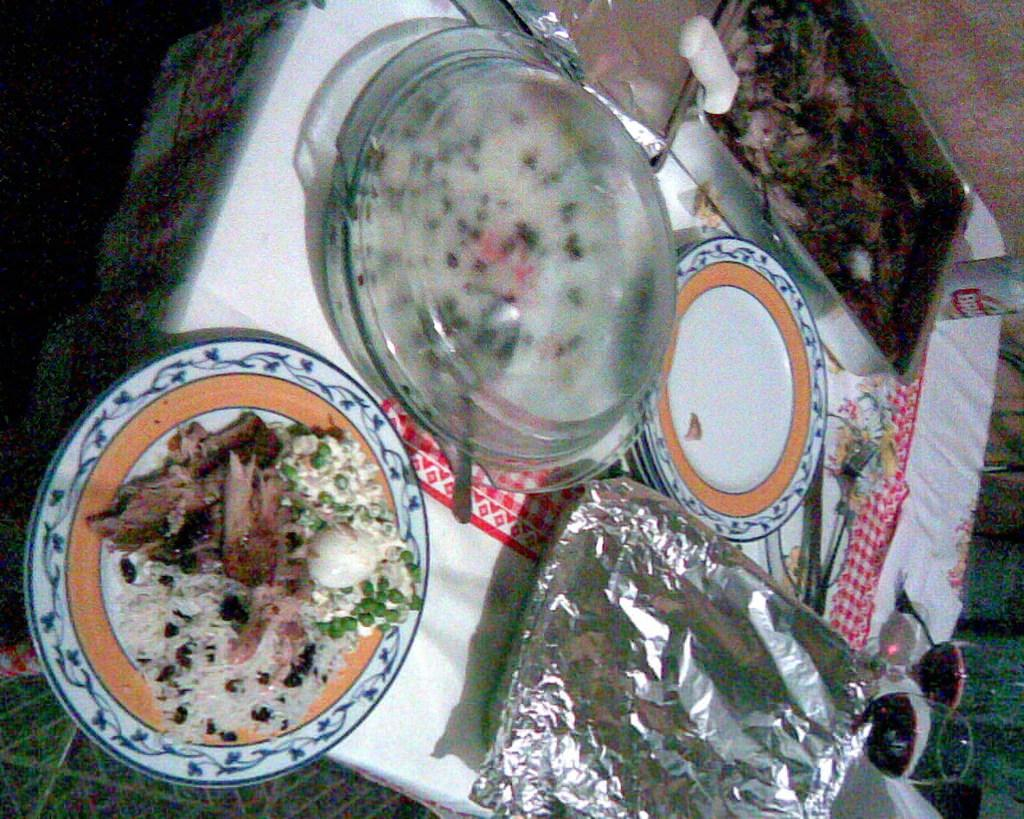What is the main piece of furniture in the image? There is a table in the image. Where is the table located? The table is on the ground. What is covering the table? There is a cloth on the table. What items can be seen on the table? There are plates, food, a bowl, trays, forks, aluminum foils, and a coke tin on the table. Are there any dinosaurs visible on the table in the image? No, there are no dinosaurs present in the image. What direction is the table facing in the image? The facts provided do not give information about the direction the table is facing, so it cannot be determined from the image. 